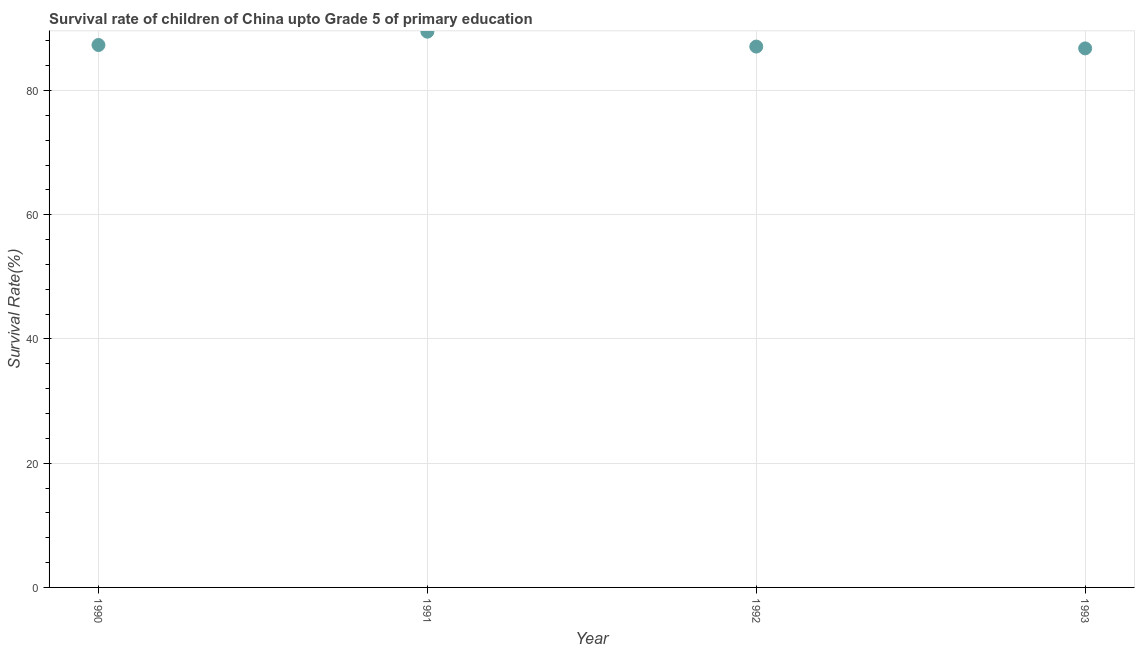What is the survival rate in 1992?
Give a very brief answer. 87.07. Across all years, what is the maximum survival rate?
Your answer should be very brief. 89.47. Across all years, what is the minimum survival rate?
Keep it short and to the point. 86.77. In which year was the survival rate minimum?
Give a very brief answer. 1993. What is the sum of the survival rate?
Offer a terse response. 350.62. What is the difference between the survival rate in 1990 and 1992?
Offer a terse response. 0.25. What is the average survival rate per year?
Your answer should be very brief. 87.66. What is the median survival rate?
Provide a short and direct response. 87.19. Do a majority of the years between 1992 and 1991 (inclusive) have survival rate greater than 72 %?
Make the answer very short. No. What is the ratio of the survival rate in 1990 to that in 1992?
Your response must be concise. 1. Is the survival rate in 1990 less than that in 1992?
Your response must be concise. No. What is the difference between the highest and the second highest survival rate?
Keep it short and to the point. 2.15. Is the sum of the survival rate in 1990 and 1992 greater than the maximum survival rate across all years?
Your response must be concise. Yes. What is the difference between the highest and the lowest survival rate?
Your answer should be compact. 2.69. How many years are there in the graph?
Your answer should be very brief. 4. Are the values on the major ticks of Y-axis written in scientific E-notation?
Your answer should be very brief. No. What is the title of the graph?
Your answer should be compact. Survival rate of children of China upto Grade 5 of primary education. What is the label or title of the X-axis?
Give a very brief answer. Year. What is the label or title of the Y-axis?
Make the answer very short. Survival Rate(%). What is the Survival Rate(%) in 1990?
Your answer should be compact. 87.32. What is the Survival Rate(%) in 1991?
Your response must be concise. 89.47. What is the Survival Rate(%) in 1992?
Offer a very short reply. 87.07. What is the Survival Rate(%) in 1993?
Offer a terse response. 86.77. What is the difference between the Survival Rate(%) in 1990 and 1991?
Keep it short and to the point. -2.15. What is the difference between the Survival Rate(%) in 1990 and 1992?
Offer a terse response. 0.25. What is the difference between the Survival Rate(%) in 1990 and 1993?
Your answer should be compact. 0.55. What is the difference between the Survival Rate(%) in 1991 and 1992?
Make the answer very short. 2.4. What is the difference between the Survival Rate(%) in 1991 and 1993?
Your answer should be compact. 2.69. What is the difference between the Survival Rate(%) in 1992 and 1993?
Your answer should be compact. 0.29. What is the ratio of the Survival Rate(%) in 1990 to that in 1991?
Make the answer very short. 0.98. What is the ratio of the Survival Rate(%) in 1990 to that in 1993?
Ensure brevity in your answer.  1.01. What is the ratio of the Survival Rate(%) in 1991 to that in 1992?
Your answer should be very brief. 1.03. What is the ratio of the Survival Rate(%) in 1991 to that in 1993?
Offer a terse response. 1.03. What is the ratio of the Survival Rate(%) in 1992 to that in 1993?
Provide a succinct answer. 1. 